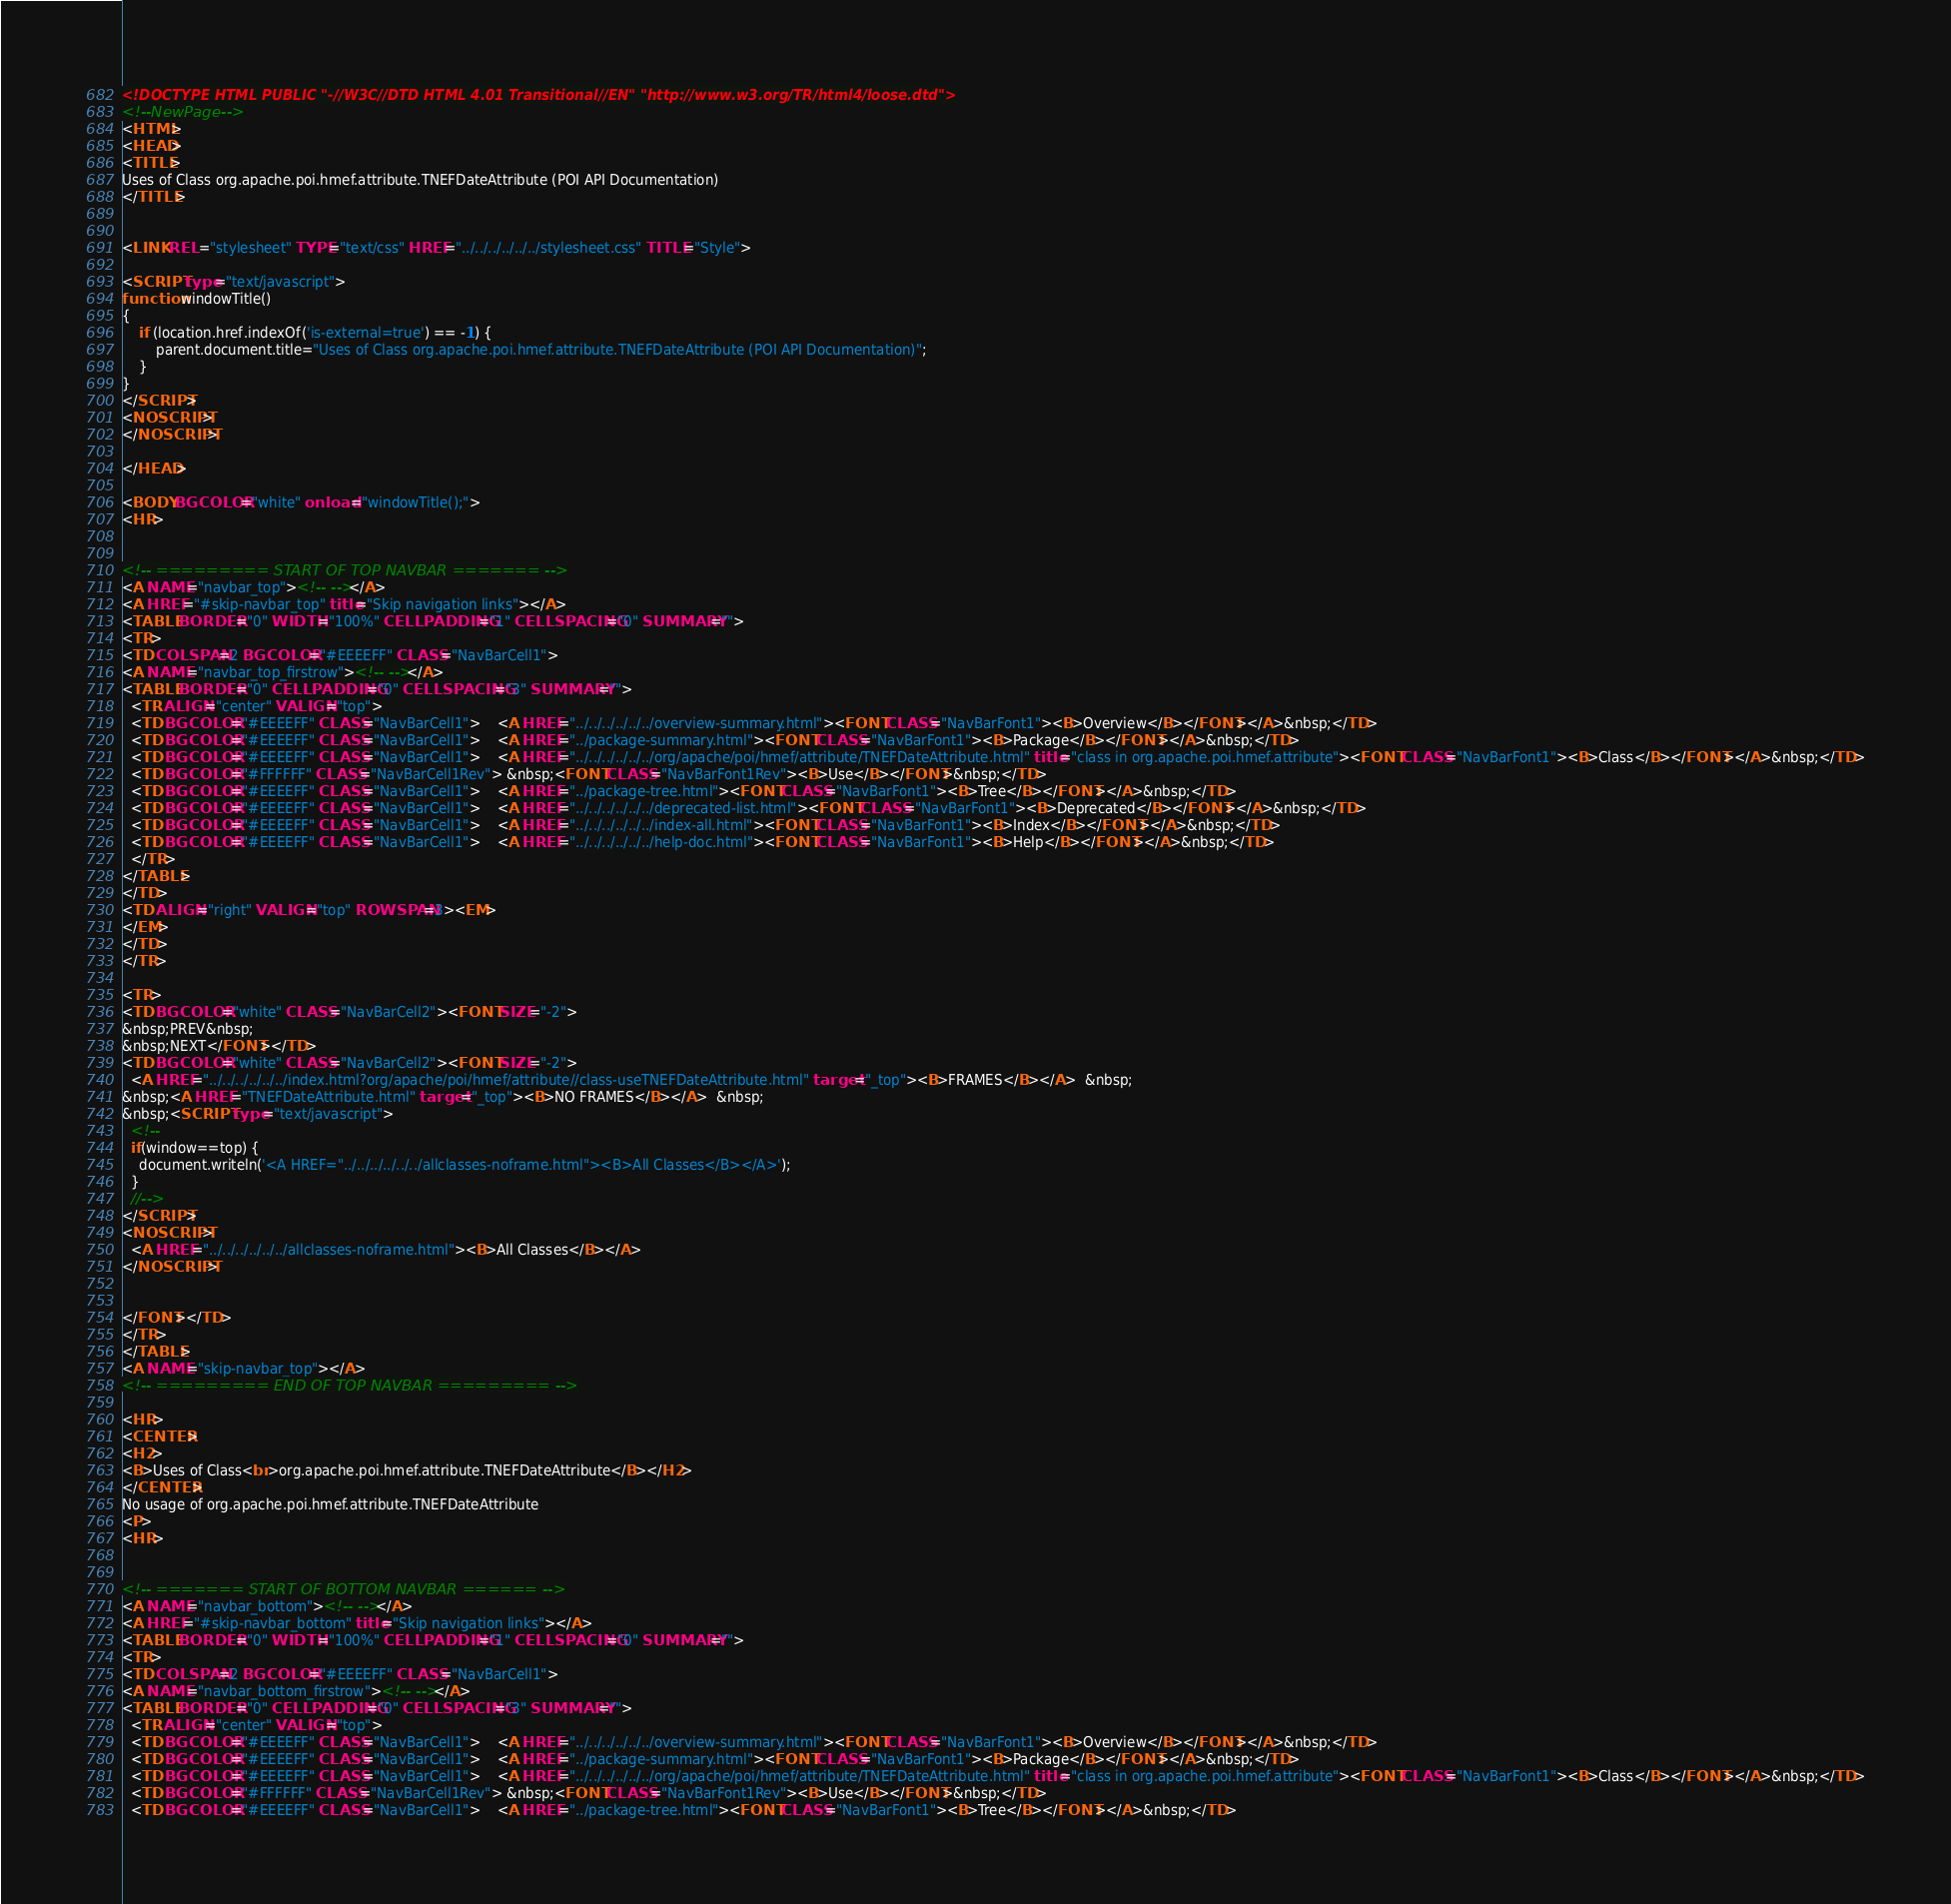<code> <loc_0><loc_0><loc_500><loc_500><_HTML_><!DOCTYPE HTML PUBLIC "-//W3C//DTD HTML 4.01 Transitional//EN" "http://www.w3.org/TR/html4/loose.dtd">
<!--NewPage-->
<HTML>
<HEAD>
<TITLE>
Uses of Class org.apache.poi.hmef.attribute.TNEFDateAttribute (POI API Documentation)
</TITLE>


<LINK REL ="stylesheet" TYPE="text/css" HREF="../../../../../../stylesheet.css" TITLE="Style">

<SCRIPT type="text/javascript">
function windowTitle()
{
    if (location.href.indexOf('is-external=true') == -1) {
        parent.document.title="Uses of Class org.apache.poi.hmef.attribute.TNEFDateAttribute (POI API Documentation)";
    }
}
</SCRIPT>
<NOSCRIPT>
</NOSCRIPT>

</HEAD>

<BODY BGCOLOR="white" onload="windowTitle();">
<HR>


<!-- ========= START OF TOP NAVBAR ======= -->
<A NAME="navbar_top"><!-- --></A>
<A HREF="#skip-navbar_top" title="Skip navigation links"></A>
<TABLE BORDER="0" WIDTH="100%" CELLPADDING="1" CELLSPACING="0" SUMMARY="">
<TR>
<TD COLSPAN=2 BGCOLOR="#EEEEFF" CLASS="NavBarCell1">
<A NAME="navbar_top_firstrow"><!-- --></A>
<TABLE BORDER="0" CELLPADDING="0" CELLSPACING="3" SUMMARY="">
  <TR ALIGN="center" VALIGN="top">
  <TD BGCOLOR="#EEEEFF" CLASS="NavBarCell1">    <A HREF="../../../../../../overview-summary.html"><FONT CLASS="NavBarFont1"><B>Overview</B></FONT></A>&nbsp;</TD>
  <TD BGCOLOR="#EEEEFF" CLASS="NavBarCell1">    <A HREF="../package-summary.html"><FONT CLASS="NavBarFont1"><B>Package</B></FONT></A>&nbsp;</TD>
  <TD BGCOLOR="#EEEEFF" CLASS="NavBarCell1">    <A HREF="../../../../../../org/apache/poi/hmef/attribute/TNEFDateAttribute.html" title="class in org.apache.poi.hmef.attribute"><FONT CLASS="NavBarFont1"><B>Class</B></FONT></A>&nbsp;</TD>
  <TD BGCOLOR="#FFFFFF" CLASS="NavBarCell1Rev"> &nbsp;<FONT CLASS="NavBarFont1Rev"><B>Use</B></FONT>&nbsp;</TD>
  <TD BGCOLOR="#EEEEFF" CLASS="NavBarCell1">    <A HREF="../package-tree.html"><FONT CLASS="NavBarFont1"><B>Tree</B></FONT></A>&nbsp;</TD>
  <TD BGCOLOR="#EEEEFF" CLASS="NavBarCell1">    <A HREF="../../../../../../deprecated-list.html"><FONT CLASS="NavBarFont1"><B>Deprecated</B></FONT></A>&nbsp;</TD>
  <TD BGCOLOR="#EEEEFF" CLASS="NavBarCell1">    <A HREF="../../../../../../index-all.html"><FONT CLASS="NavBarFont1"><B>Index</B></FONT></A>&nbsp;</TD>
  <TD BGCOLOR="#EEEEFF" CLASS="NavBarCell1">    <A HREF="../../../../../../help-doc.html"><FONT CLASS="NavBarFont1"><B>Help</B></FONT></A>&nbsp;</TD>
  </TR>
</TABLE>
</TD>
<TD ALIGN="right" VALIGN="top" ROWSPAN=3><EM>
</EM>
</TD>
</TR>

<TR>
<TD BGCOLOR="white" CLASS="NavBarCell2"><FONT SIZE="-2">
&nbsp;PREV&nbsp;
&nbsp;NEXT</FONT></TD>
<TD BGCOLOR="white" CLASS="NavBarCell2"><FONT SIZE="-2">
  <A HREF="../../../../../../index.html?org/apache/poi/hmef/attribute//class-useTNEFDateAttribute.html" target="_top"><B>FRAMES</B></A>  &nbsp;
&nbsp;<A HREF="TNEFDateAttribute.html" target="_top"><B>NO FRAMES</B></A>  &nbsp;
&nbsp;<SCRIPT type="text/javascript">
  <!--
  if(window==top) {
    document.writeln('<A HREF="../../../../../../allclasses-noframe.html"><B>All Classes</B></A>');
  }
  //-->
</SCRIPT>
<NOSCRIPT>
  <A HREF="../../../../../../allclasses-noframe.html"><B>All Classes</B></A>
</NOSCRIPT>


</FONT></TD>
</TR>
</TABLE>
<A NAME="skip-navbar_top"></A>
<!-- ========= END OF TOP NAVBAR ========= -->

<HR>
<CENTER>
<H2>
<B>Uses of Class<br>org.apache.poi.hmef.attribute.TNEFDateAttribute</B></H2>
</CENTER>
No usage of org.apache.poi.hmef.attribute.TNEFDateAttribute
<P>
<HR>


<!-- ======= START OF BOTTOM NAVBAR ====== -->
<A NAME="navbar_bottom"><!-- --></A>
<A HREF="#skip-navbar_bottom" title="Skip navigation links"></A>
<TABLE BORDER="0" WIDTH="100%" CELLPADDING="1" CELLSPACING="0" SUMMARY="">
<TR>
<TD COLSPAN=2 BGCOLOR="#EEEEFF" CLASS="NavBarCell1">
<A NAME="navbar_bottom_firstrow"><!-- --></A>
<TABLE BORDER="0" CELLPADDING="0" CELLSPACING="3" SUMMARY="">
  <TR ALIGN="center" VALIGN="top">
  <TD BGCOLOR="#EEEEFF" CLASS="NavBarCell1">    <A HREF="../../../../../../overview-summary.html"><FONT CLASS="NavBarFont1"><B>Overview</B></FONT></A>&nbsp;</TD>
  <TD BGCOLOR="#EEEEFF" CLASS="NavBarCell1">    <A HREF="../package-summary.html"><FONT CLASS="NavBarFont1"><B>Package</B></FONT></A>&nbsp;</TD>
  <TD BGCOLOR="#EEEEFF" CLASS="NavBarCell1">    <A HREF="../../../../../../org/apache/poi/hmef/attribute/TNEFDateAttribute.html" title="class in org.apache.poi.hmef.attribute"><FONT CLASS="NavBarFont1"><B>Class</B></FONT></A>&nbsp;</TD>
  <TD BGCOLOR="#FFFFFF" CLASS="NavBarCell1Rev"> &nbsp;<FONT CLASS="NavBarFont1Rev"><B>Use</B></FONT>&nbsp;</TD>
  <TD BGCOLOR="#EEEEFF" CLASS="NavBarCell1">    <A HREF="../package-tree.html"><FONT CLASS="NavBarFont1"><B>Tree</B></FONT></A>&nbsp;</TD></code> 